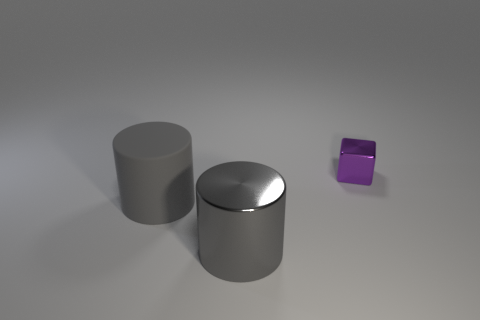Add 1 blocks. How many objects exist? 4 Subtract all blocks. How many objects are left? 2 Add 3 gray matte things. How many gray matte things exist? 4 Subtract 0 cyan cubes. How many objects are left? 3 Subtract all rubber cylinders. Subtract all tiny purple blocks. How many objects are left? 1 Add 1 big matte things. How many big matte things are left? 2 